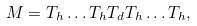Convert formula to latex. <formula><loc_0><loc_0><loc_500><loc_500>M = T _ { h } \dots T _ { h } T _ { d } T _ { h } \dots T _ { h } ,</formula> 